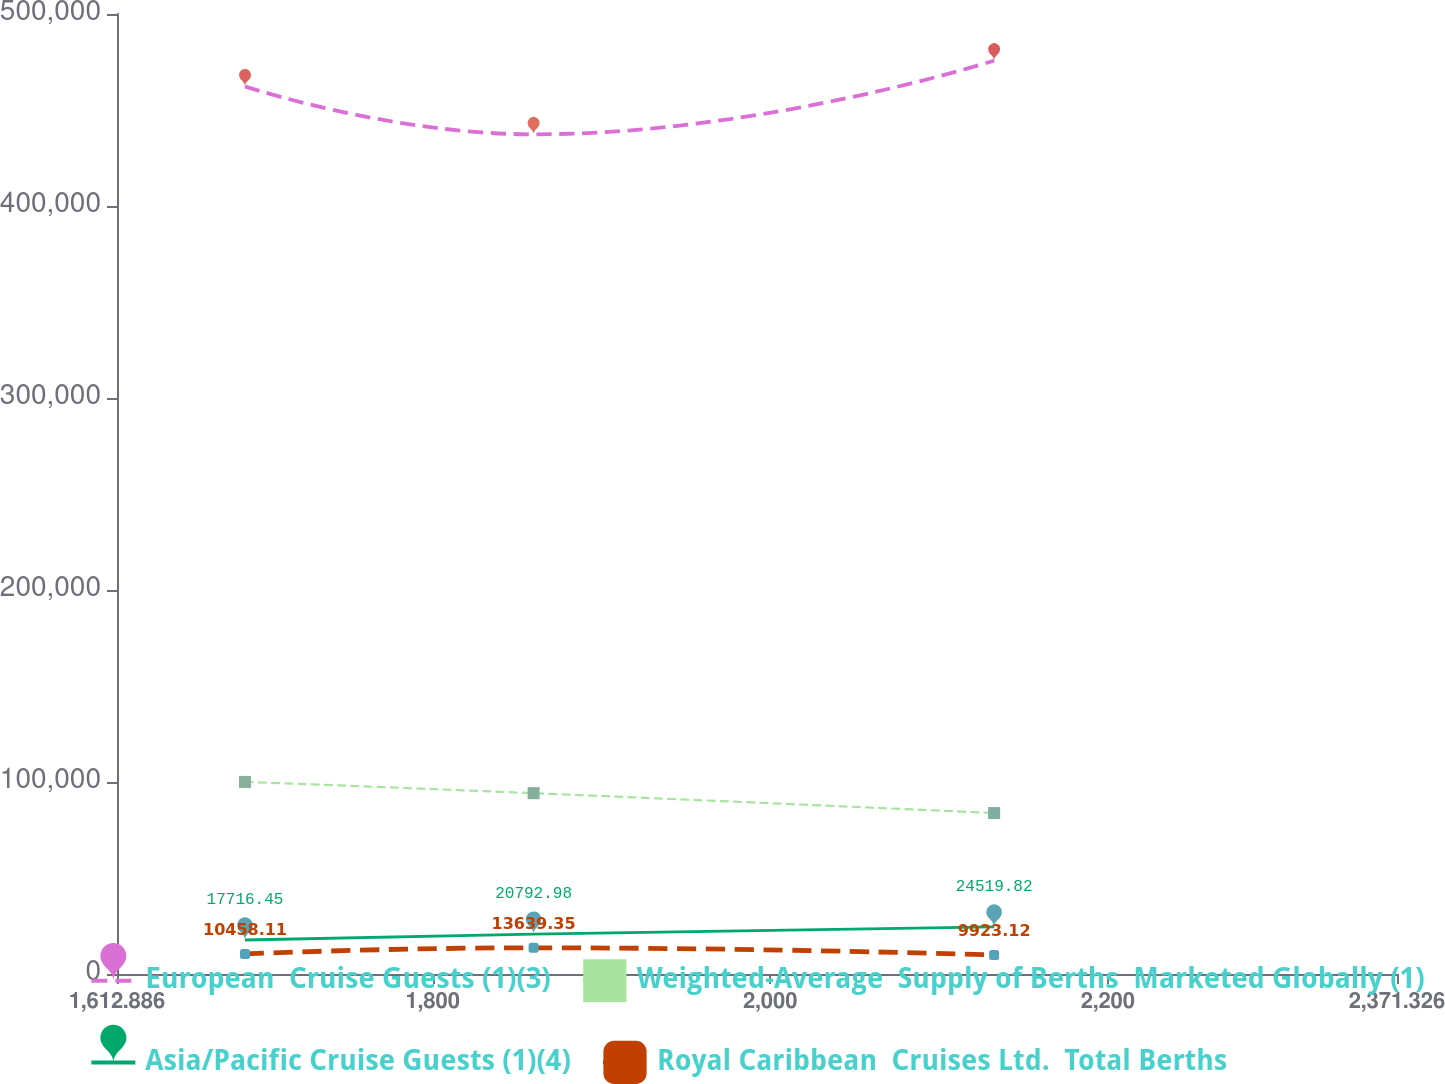Convert chart to OTSL. <chart><loc_0><loc_0><loc_500><loc_500><line_chart><ecel><fcel>European  Cruise Guests (1)(3)<fcel>Weighted-Average  Supply of Berths  Marketed Globally (1)<fcel>Asia/Pacific Cruise Guests (1)(4)<fcel>Royal Caribbean  Cruises Ltd.  Total Berths<nl><fcel>1688.73<fcel>462317<fcel>100041<fcel>17716.5<fcel>10458.1<nl><fcel>1859.73<fcel>437335<fcel>94174.1<fcel>20793<fcel>13639.4<nl><fcel>2132.61<fcel>475753<fcel>83828.6<fcel>24519.8<fcel>9923.12<nl><fcel>2375.19<fcel>503125<fcel>105511<fcel>25773.5<fcel>14046.2<nl><fcel>2447.17<fcel>420738<fcel>132851<fcel>19031.9<fcel>10929.8<nl></chart> 